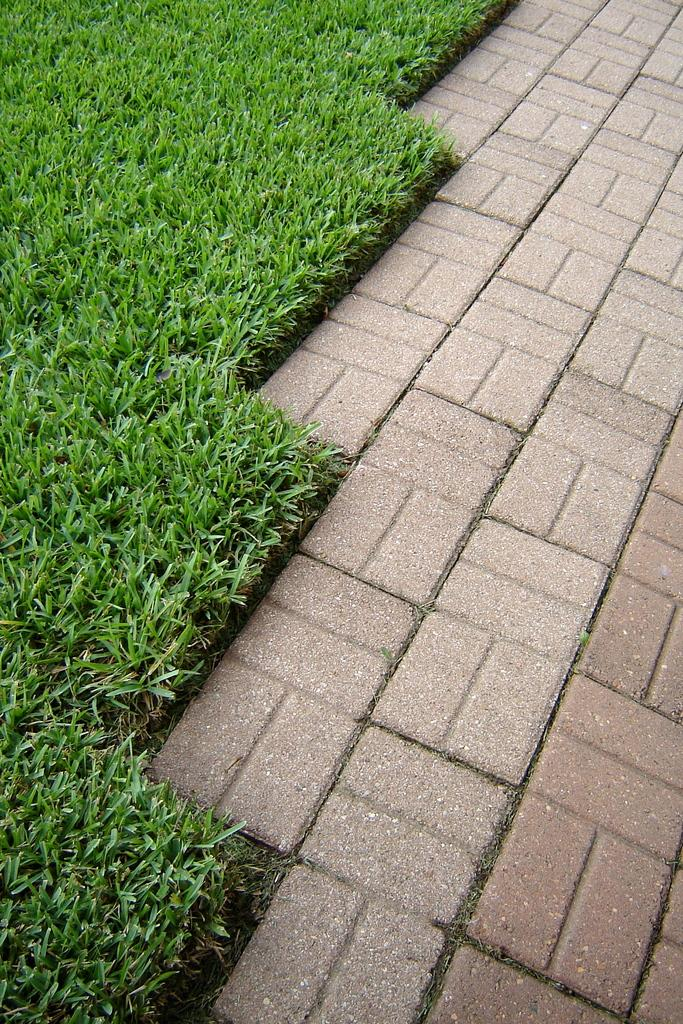What type of vegetation is on the left side of the image? There is grass on the left side of the image. Where is the grass located in the image? The grass is present on the ground. What can be seen on the right side of the image? There is a walking path on the right side of the image. How many bikes are parked next to the grass in the image? There are no bikes present in the image. Can you see a rabbit hopping on the walking path in the image? There is no rabbit visible in the image. 